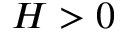Convert formula to latex. <formula><loc_0><loc_0><loc_500><loc_500>H > 0</formula> 